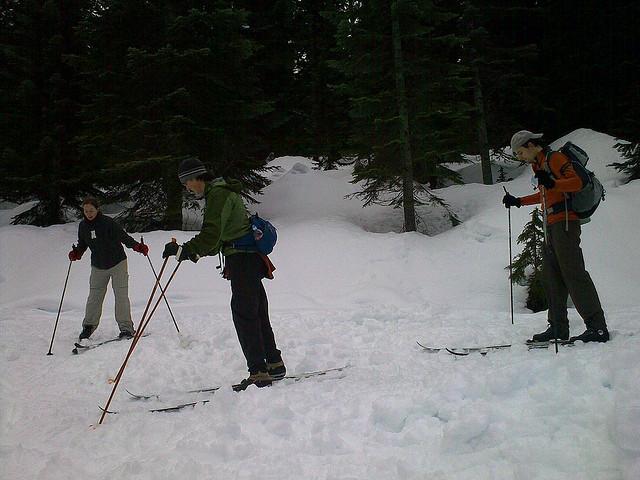Do the people seem happy?
Short answer required. Yes. Are all the people wearing hats?
Keep it brief. Yes. How many people are in this photo?
Keep it brief. 3. How many people are skiing?
Short answer required. 3. Are the boys skiing?
Give a very brief answer. Yes. Did it just snow?
Keep it brief. Yes. How many skies are there?
Keep it brief. 6. What direction are the men facing?
Write a very short answer. Left. 